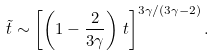Convert formula to latex. <formula><loc_0><loc_0><loc_500><loc_500>\tilde { t } \sim \left [ \left ( 1 - \frac { 2 } { 3 \gamma } \right ) \, t \right ] ^ { 3 \gamma / ( 3 \gamma - 2 ) } .</formula> 